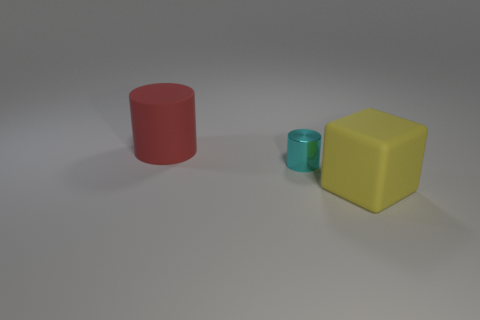Add 2 red cylinders. How many objects exist? 5 Subtract 1 cylinders. How many cylinders are left? 1 Add 2 large red matte cylinders. How many large red matte cylinders are left? 3 Add 2 cylinders. How many cylinders exist? 4 Subtract all red cylinders. How many cylinders are left? 1 Subtract 0 gray blocks. How many objects are left? 3 Subtract all cylinders. How many objects are left? 1 Subtract all purple cubes. Subtract all green cylinders. How many cubes are left? 1 Subtract all purple cubes. How many green cylinders are left? 0 Subtract all cyan cylinders. Subtract all red rubber objects. How many objects are left? 1 